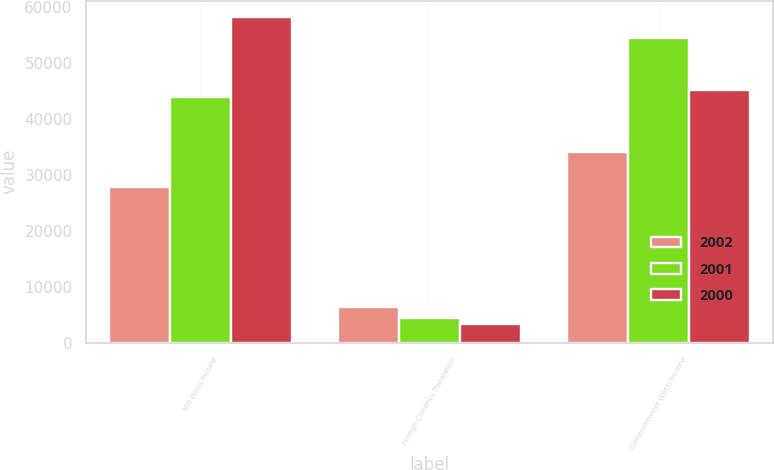Convert chart to OTSL. <chart><loc_0><loc_0><loc_500><loc_500><stacked_bar_chart><ecel><fcel>Net (loss) income<fcel>Foreign Currency Translation<fcel>Comprehensive (Loss) Income<nl><fcel>2002<fcel>27825<fcel>6373<fcel>34198<nl><fcel>2001<fcel>44057<fcel>4388<fcel>54516<nl><fcel>2000<fcel>58292<fcel>3378<fcel>45279<nl></chart> 